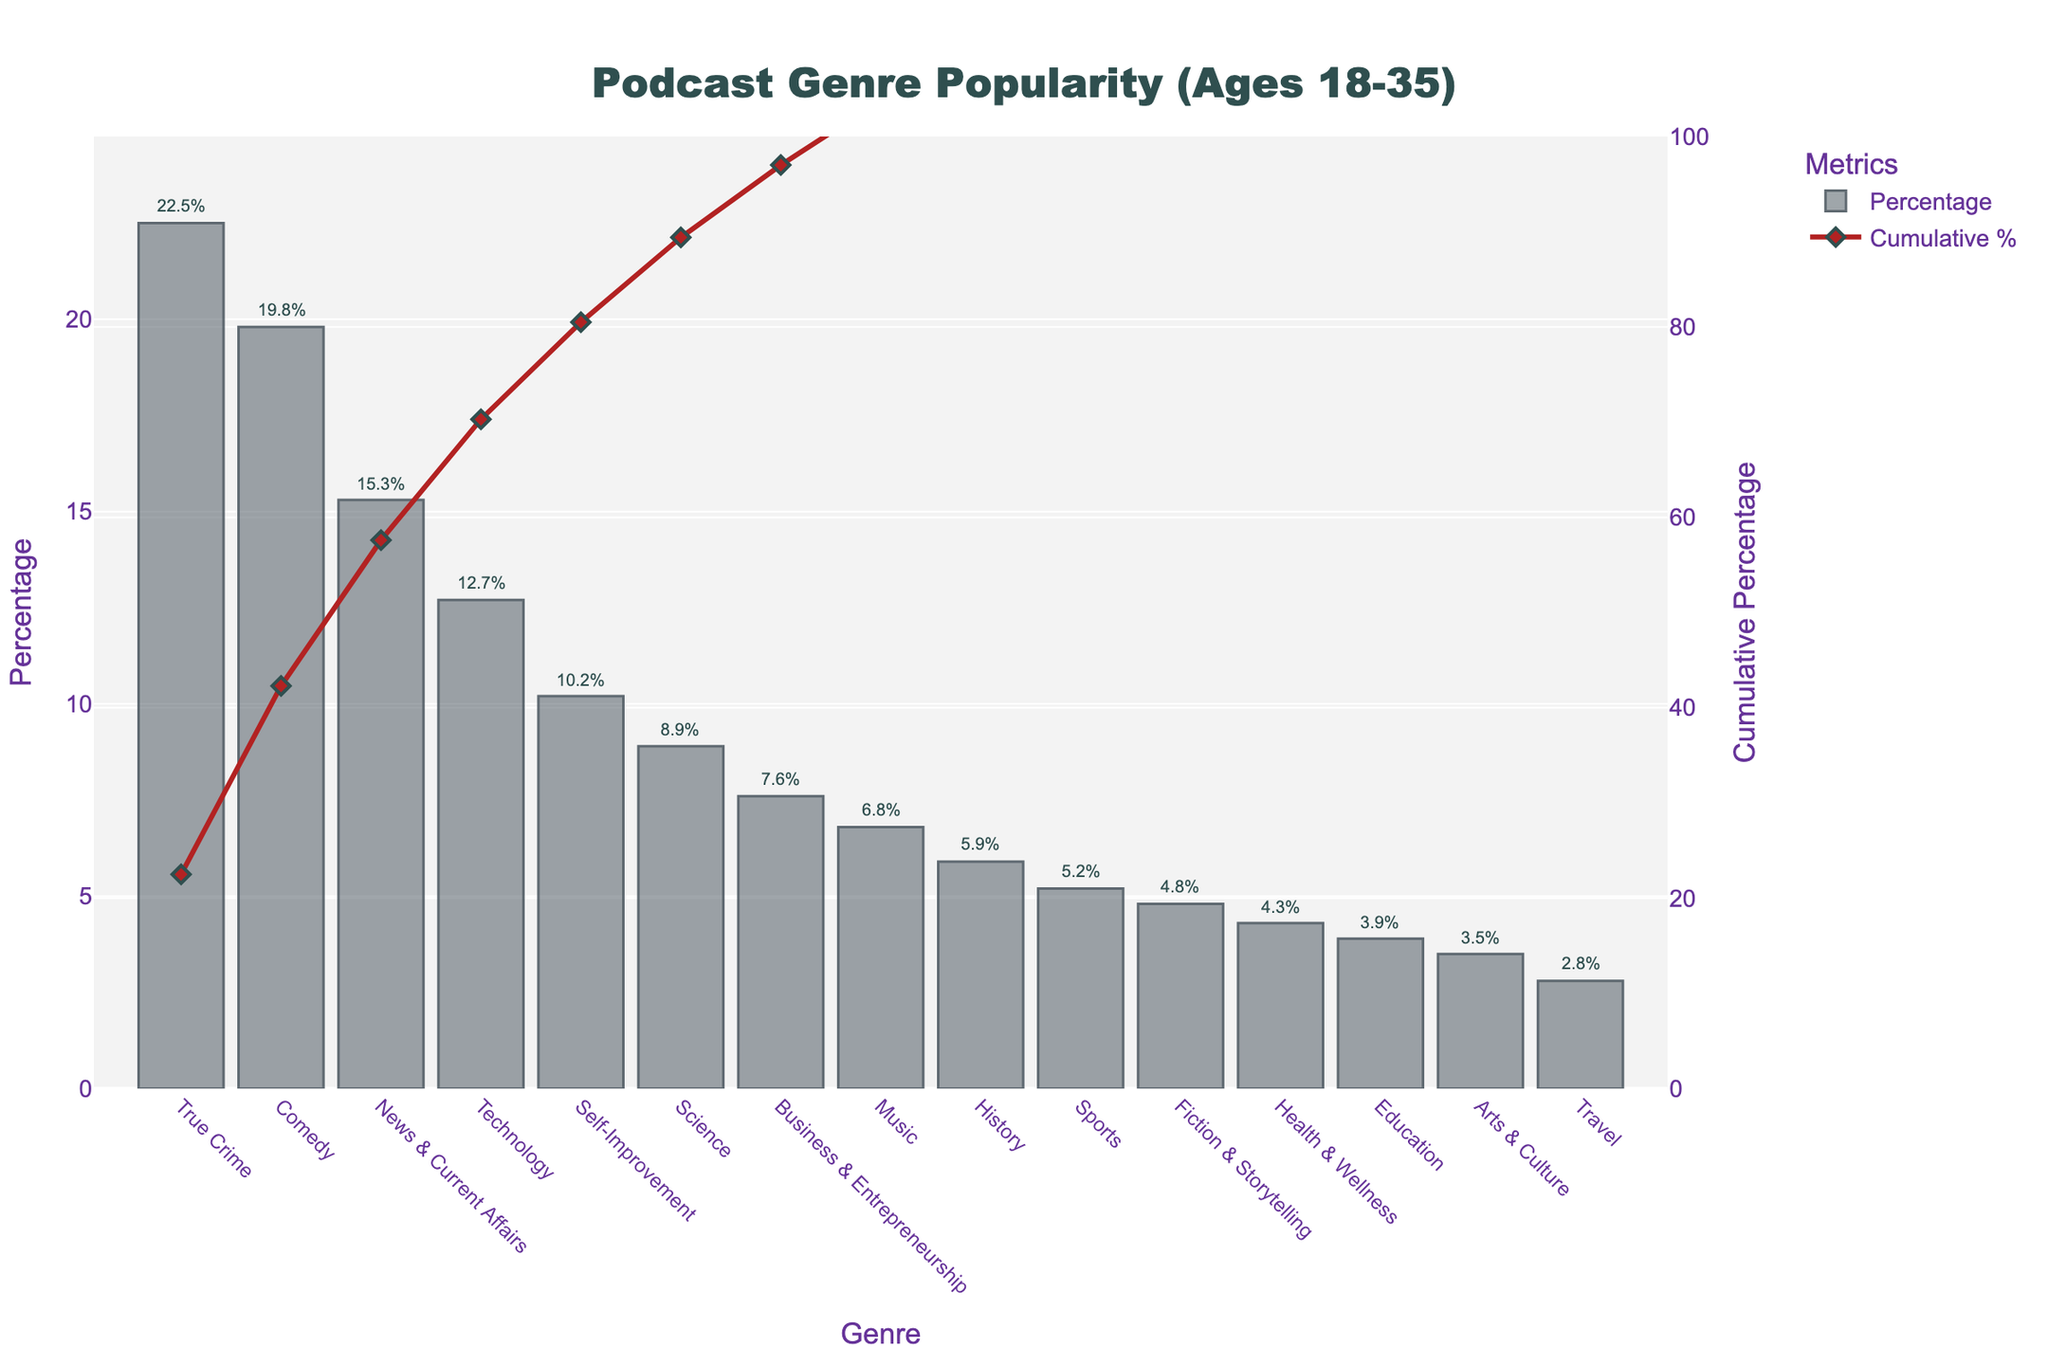What is the most popular podcast genre among listeners aged 18-35? From the bar chart, the highest bar represents True Crime with a percentage of 22.5, making it the most popular genre.
Answer: True Crime Which genre has a higher percentage: Self-Improvement or Science? Comparing the heights of the bars for Self-Improvement and Science, Self-Improvement has a higher percentage at 10.2% compared to Science at 8.9%.
Answer: Self-Improvement What is the cumulative percentage of podcast genres up to Comedy? The cumulative percentage line marks at Comedy can be tracked which includes True Crime (22.5%) and Comedy itself. Adding them gives 22.5 + 19.8 = 42.3%.
Answer: 42.3% Among the genres Technology, Business & Entrepreneurship, and Music, which one is the least popular? By comparing the heights of the bars, Music has the lowest percentage at 6.8% compared to Technology (12.7%) and Business & Entrepreneurship (7.6%).
Answer: Music How much more popular is News & Current Affairs compared to Arts & Culture? The percentage for News & Current Affairs is 15.3%, while for Arts & Culture it is 3.5%. The difference between them is 15.3 - 3.5 = 11.8%.
Answer: 11.8% What is the combined percentage for the genres with the three lowest popularity values? The genres with the lowest percentages are Travel (2.8%), Arts & Culture (3.5%), and Education (3.9%). Their combined percentage is 2.8 + 3.5 + 3.9 = 10.2%.
Answer: 10.2% Which genre has exactly 4.8% popularity? From the bar chart, the genre with a bar height marking 4.8% is Fiction & Storytelling.
Answer: Fiction & Storytelling How many genres have percentages less than 10%? Counting the bars visually below the 10% mark, the genres are Science, Business & Entrepreneurship, Music, History, Sports, Fiction & Storytelling, Health & Wellness, Education, Arts & Culture, and Travel, totaling 10 genres.
Answer: 10 What is the average popularity percentage of the top five podcast genres? The top five genres are True Crime (22.5%), Comedy (19.8%), News & Current Affairs (15.3%), Technology (12.7%), and Self-Improvement (10.2%). Their average percentage is (22.5 + 19.8 + 15.3 + 12.7 + 10.2) / 5 = 80.5 / 5 = 16.1%.
Answer: 16.1% 